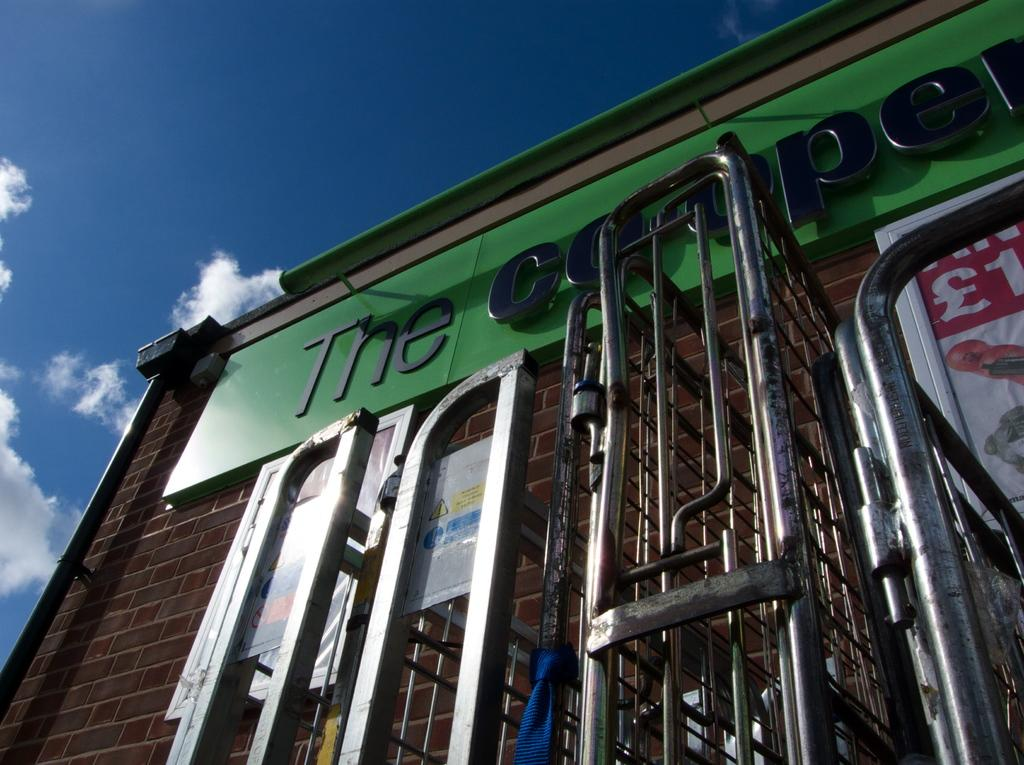<image>
Share a concise interpretation of the image provided. The store's name begins with the word "the". 